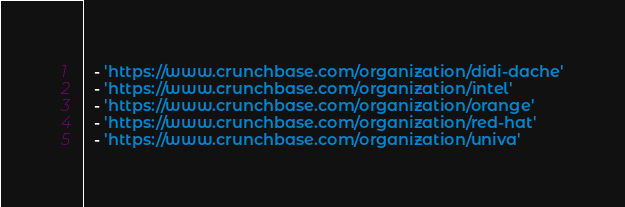Convert code to text. <code><loc_0><loc_0><loc_500><loc_500><_YAML_>  - 'https://www.crunchbase.com/organization/didi-dache'
  - 'https://www.crunchbase.com/organization/intel'
  - 'https://www.crunchbase.com/organization/orange'
  - 'https://www.crunchbase.com/organization/red-hat'
  - 'https://www.crunchbase.com/organization/univa'
</code> 